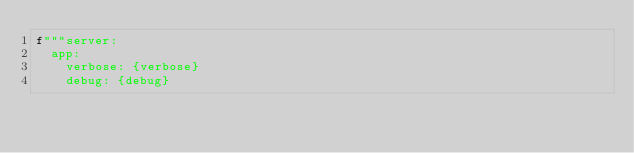<code> <loc_0><loc_0><loc_500><loc_500><_Python_>f"""server:
  app:
    verbose: {verbose}
    debug: {debug}</code> 